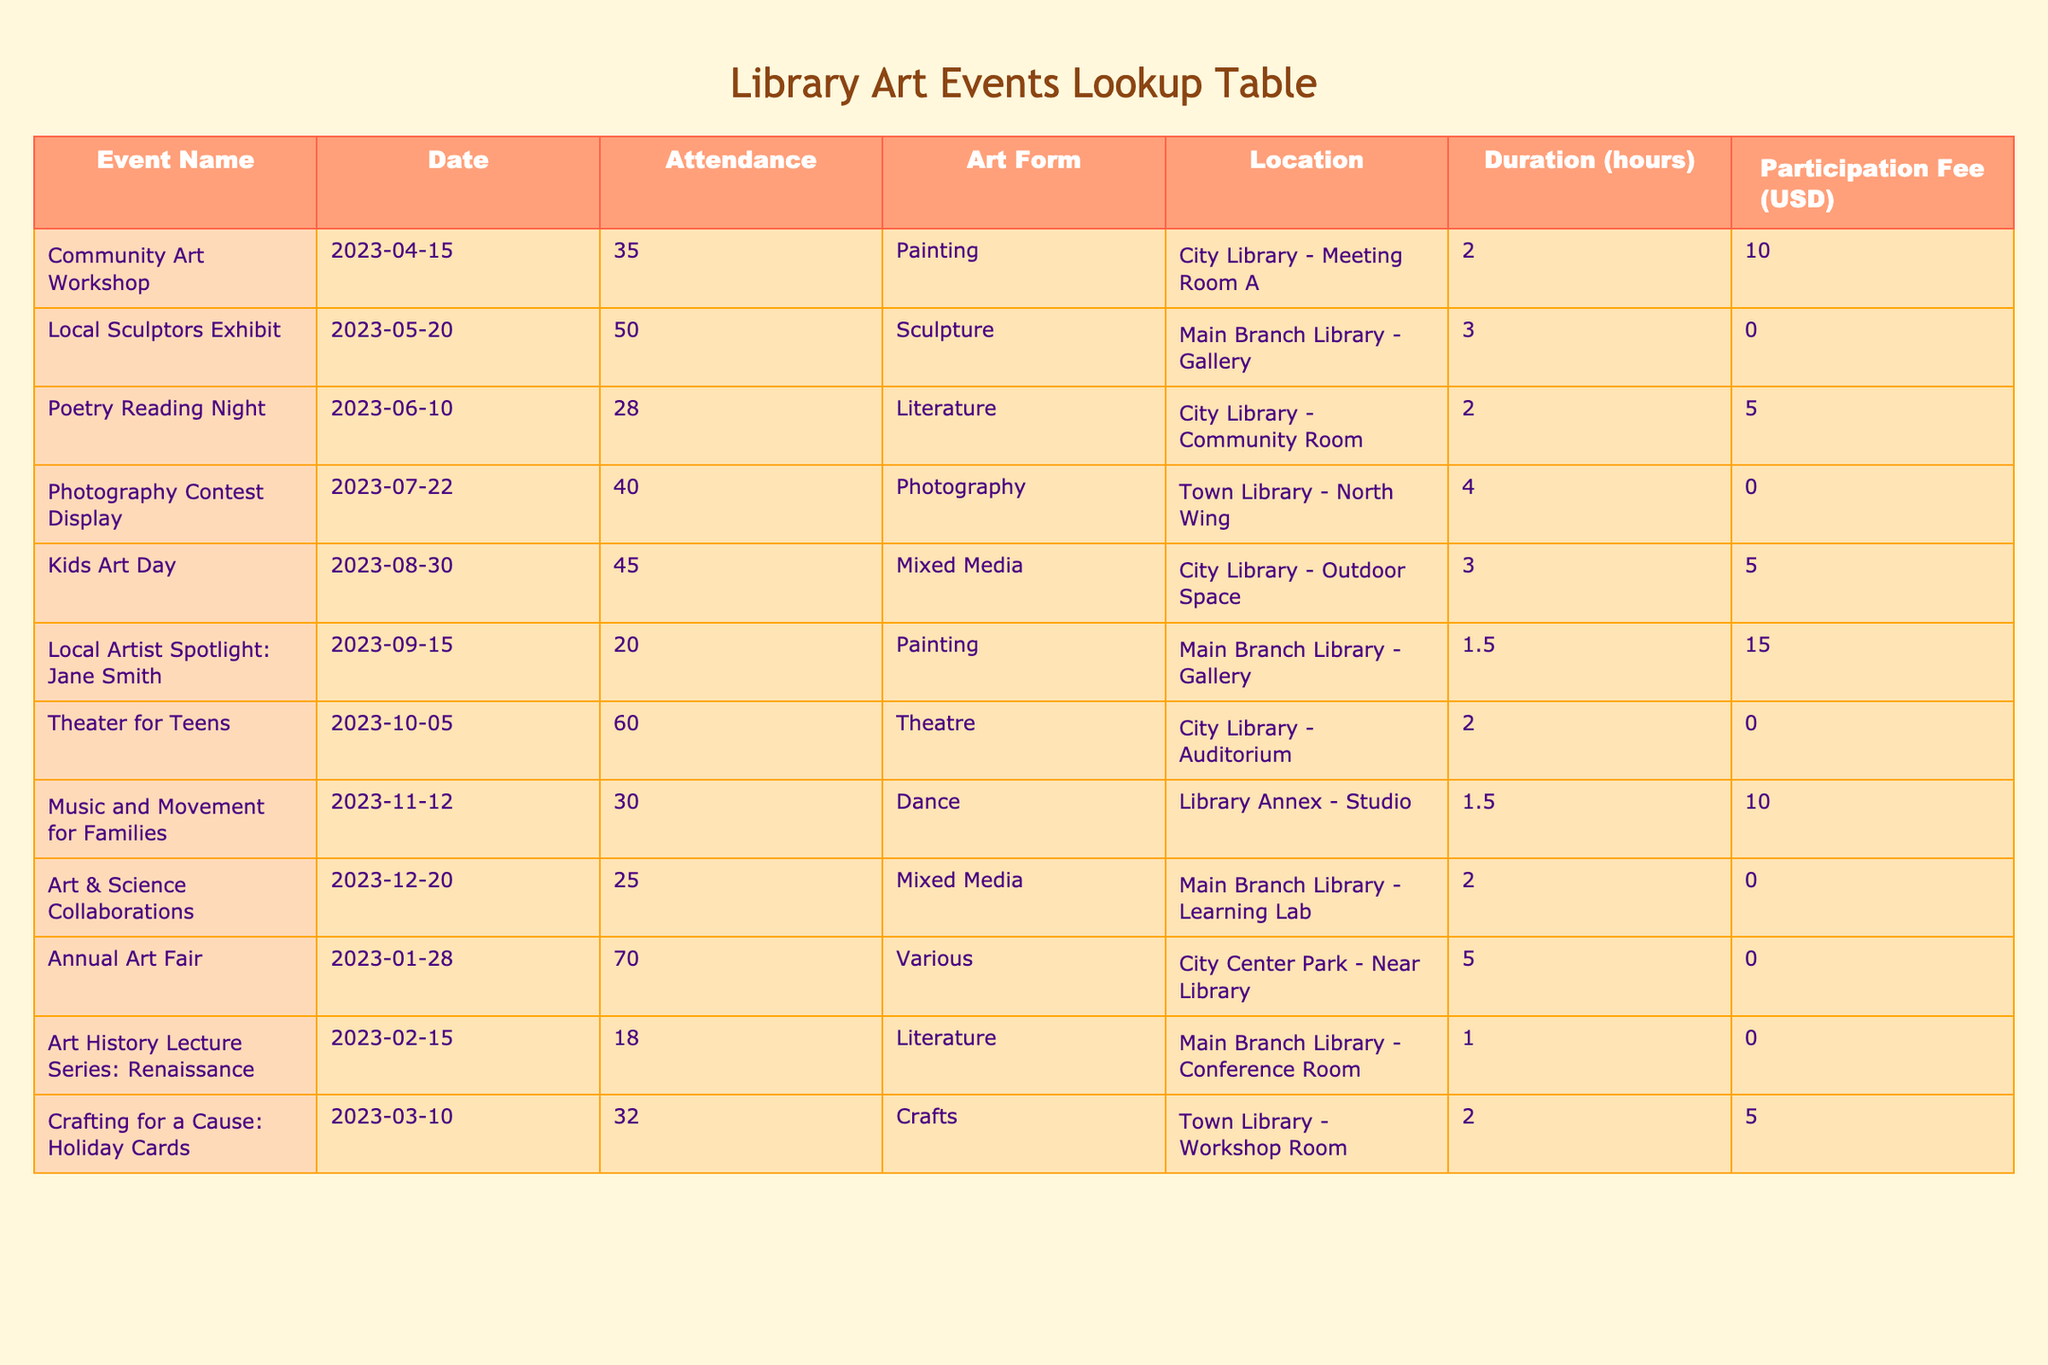What is the attendance for the "Photography Contest Display" event? The attendance for the "Photography Contest Display" event is listed in the table as 40.
Answer: 40 What is the total attendance across all library art events? To find the total attendance, we sum up the attendance values: 35 + 50 + 28 + 40 + 45 + 20 + 60 + 30 + 25 + 70 + 18 + 32 =  430.
Answer: 430 Did the "Local Sculptors Exhibit" have a participation fee? The "Local Sculptors Exhibit" is listed with a participation fee of 0, indicating there was no fee for this event.
Answer: No Which event had the highest attendance? We can identify the event with the highest attendance by looking through the table. The "Annual Art Fair" had the highest attendance of 70.
Answer: Annual Art Fair What is the average attendance for events that charged a participation fee? First, we identify the events that had a participation fee: "Community Art Workshop" (35), "Poetry Reading Night" (28), "Kids Art Day" (45), "Local Artist Spotlight: Jane Smith" (20), "Music and Movement for Families" (30), "Crafting for a Cause: Holiday Cards" (32). The total attendance for these events is 35 + 28 + 45 + 20 + 30 + 32 = 190. There are 6 events, so the average attendance is 190/6 = 31.67.
Answer: 31.67 How many events took place in the "Main Branch Library"? By examining the table, we find the events located in the "Main Branch Library" which are "Local Sculptors Exhibit," "Local Artist Spotlight: Jane Smith," "Art History Lecture Series: Renaissance," and "Art & Science Collaborations." Thus, there are 4 events in total.
Answer: 4 